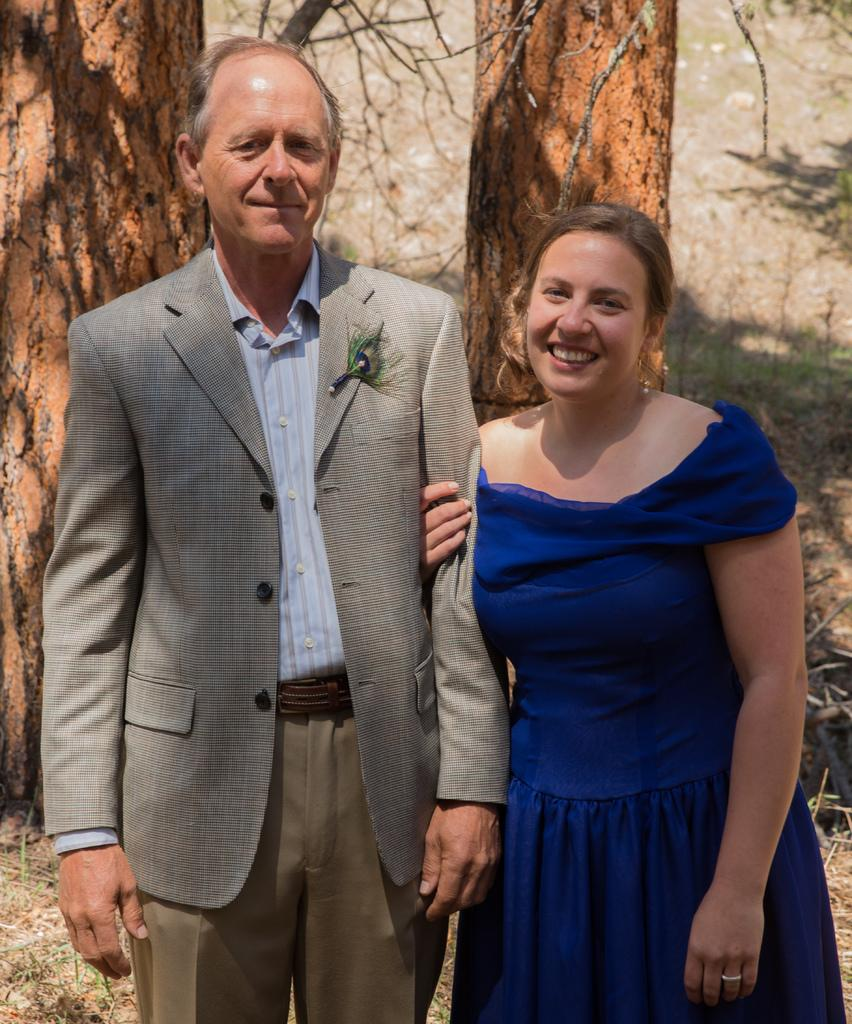How many people are in the image? There are two people in the image. What are the people wearing? The people are wearing different color dresses. Where are the people standing? The people are standing on the ground. What can be seen in the background of the image? There are many trees visible in the background of the image. What is the time shown on the heart in the image? There is no heart or time displayed in the image. 